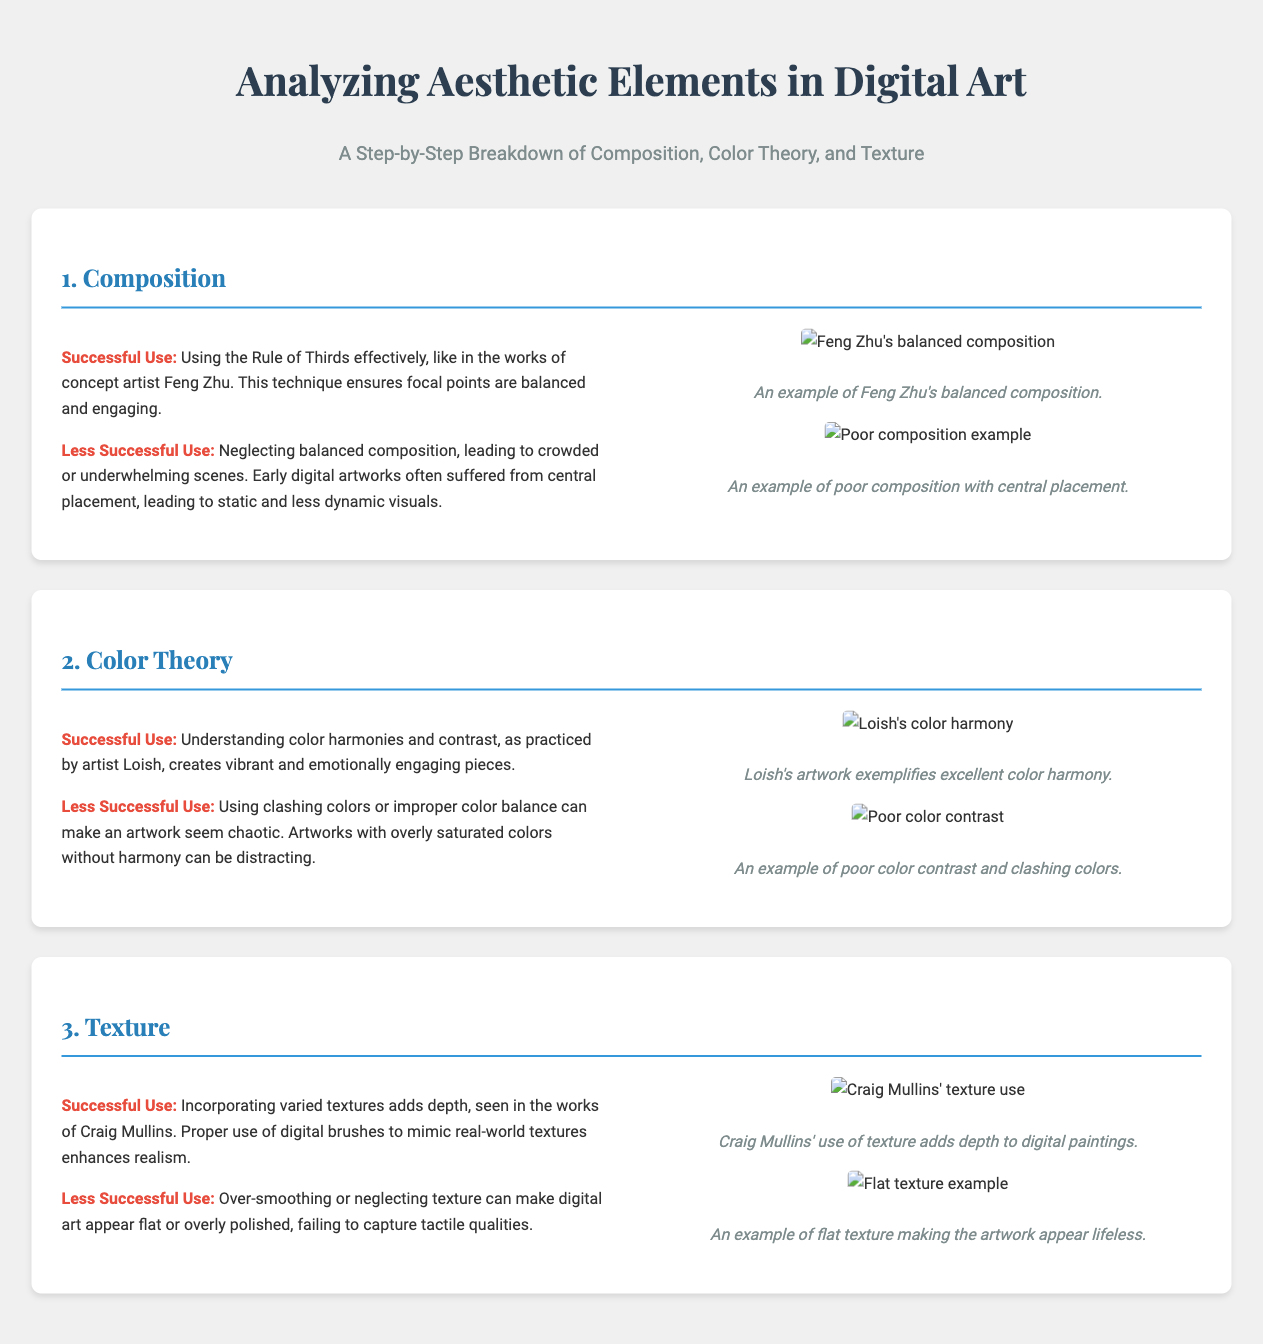What is the title of the infographic? The title of the infographic is prominently displayed at the top of the document.
Answer: Analyzing Aesthetic Elements in Digital Art Who is an example of an artist known for successful composition? The document mentions a specific artist noted for effective use of the Rule of Thirds in composition.
Answer: Feng Zhu What technique is highlighted in the successful use of color theory? The document specifies a practice that helps create vibrant and engaging pieces in digital art.
Answer: Understanding color harmonies and contrast What is a major issue with less successful color use in digital art? The document describes a specific consequence of using clashing or improperly balanced colors.
Answer: Chaos Which artist's work is referenced for successful texture use? The document provides the name of an artist recognized for incorporating varied textures to enhance depth.
Answer: Craig Mullins What visual element can lead to appearing flat in digital art? The document identifies a technique that, when overused or neglected, results in a lack of depth and realism.
Answer: Over-smoothing What is the color harmony example in the document? The document cites a specific artist whose artwork exemplifies excellent color harmony.
Answer: Loish's artwork What is the purpose of the Rule of Thirds in composition? The document briefly explains the impact of the Rule of Thirds when effectively used.
Answer: Balance and engagement 